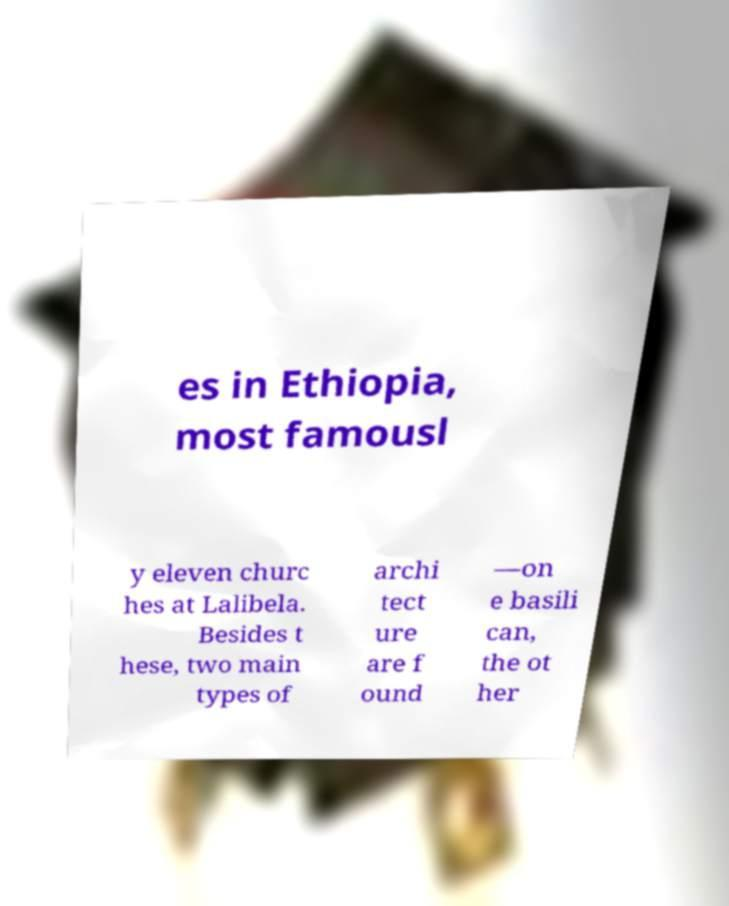Please identify and transcribe the text found in this image. es in Ethiopia, most famousl y eleven churc hes at Lalibela. Besides t hese, two main types of archi tect ure are f ound —on e basili can, the ot her 